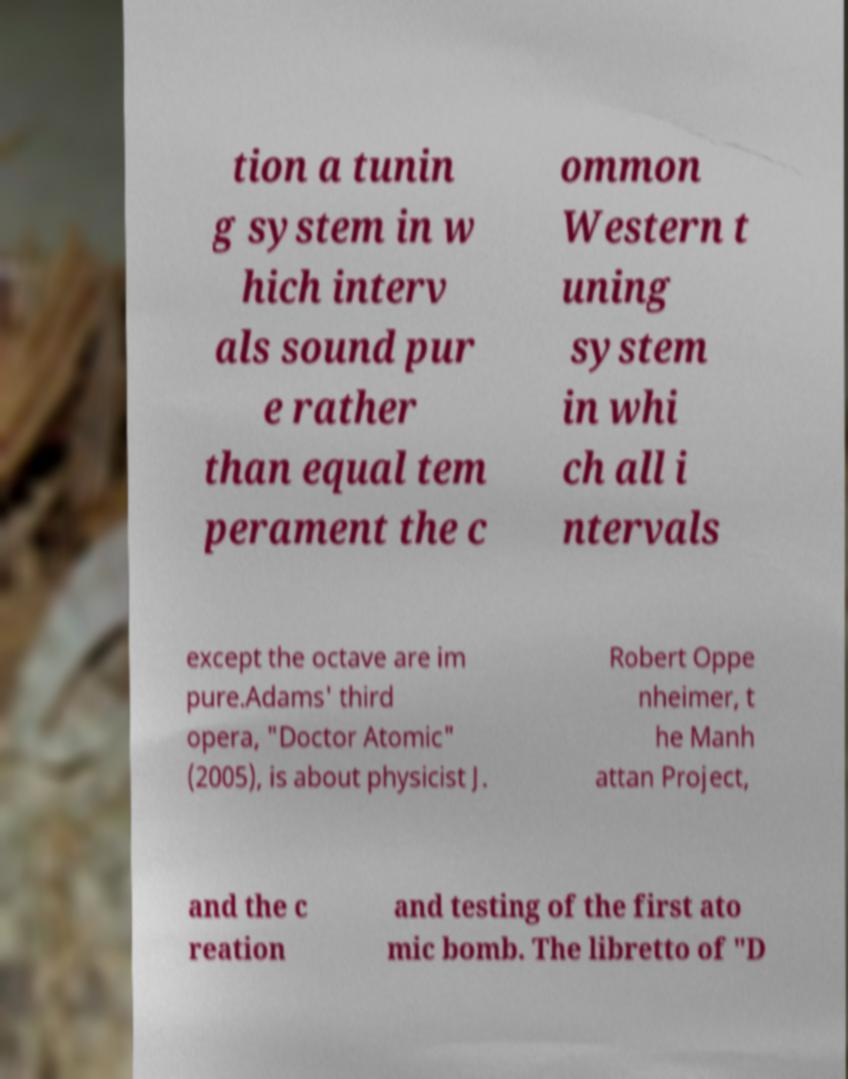For documentation purposes, I need the text within this image transcribed. Could you provide that? tion a tunin g system in w hich interv als sound pur e rather than equal tem perament the c ommon Western t uning system in whi ch all i ntervals except the octave are im pure.Adams' third opera, "Doctor Atomic" (2005), is about physicist J. Robert Oppe nheimer, t he Manh attan Project, and the c reation and testing of the first ato mic bomb. The libretto of "D 